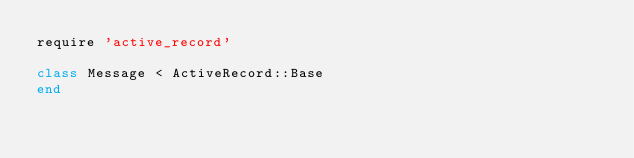<code> <loc_0><loc_0><loc_500><loc_500><_Ruby_>require 'active_record'

class Message < ActiveRecord::Base
end
</code> 